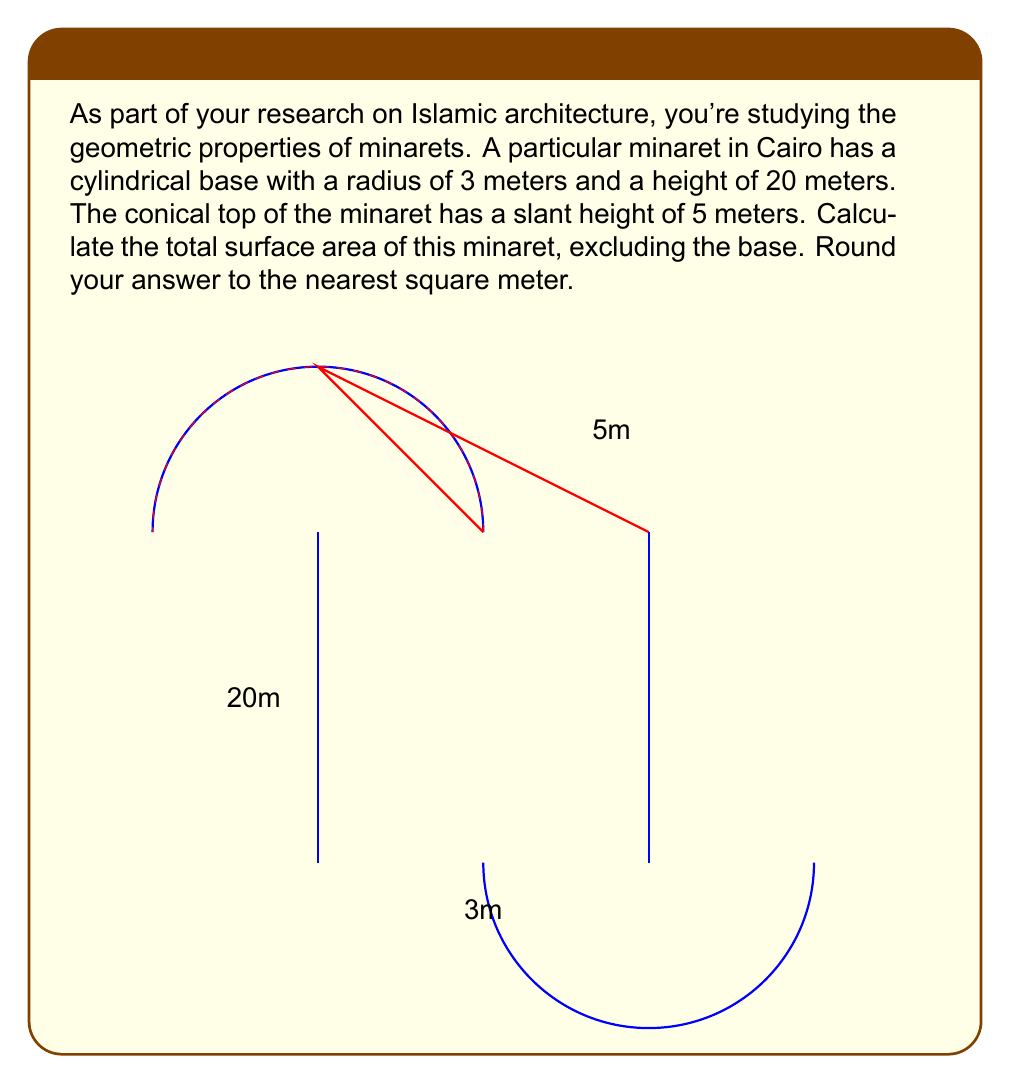Provide a solution to this math problem. To solve this problem, we need to calculate the surface area of the cylindrical part and the conical part separately, then sum them up.

1. Surface area of the cylindrical part:
   The lateral surface area of a cylinder is given by the formula $A_c = 2\pi rh$, where $r$ is the radius and $h$ is the height.
   
   $$A_c = 2\pi \cdot 3 \cdot 20 = 120\pi \text{ m}^2$$

2. Surface area of the conical part:
   The lateral surface area of a cone is given by the formula $A_n = \pi rs$, where $r$ is the radius of the base and $s$ is the slant height.
   
   $$A_n = \pi \cdot 3 \cdot 5 = 15\pi \text{ m}^2$$

3. Total surface area:
   The total surface area is the sum of the cylindrical and conical parts:
   
   $$A_{\text{total}} = A_c + A_n = 120\pi + 15\pi = 135\pi \text{ m}^2$$

4. Converting to numerical value and rounding:
   $$135\pi \approx 423.89 \text{ m}^2$$

   Rounding to the nearest square meter: 424 m²
Answer: 424 m² 